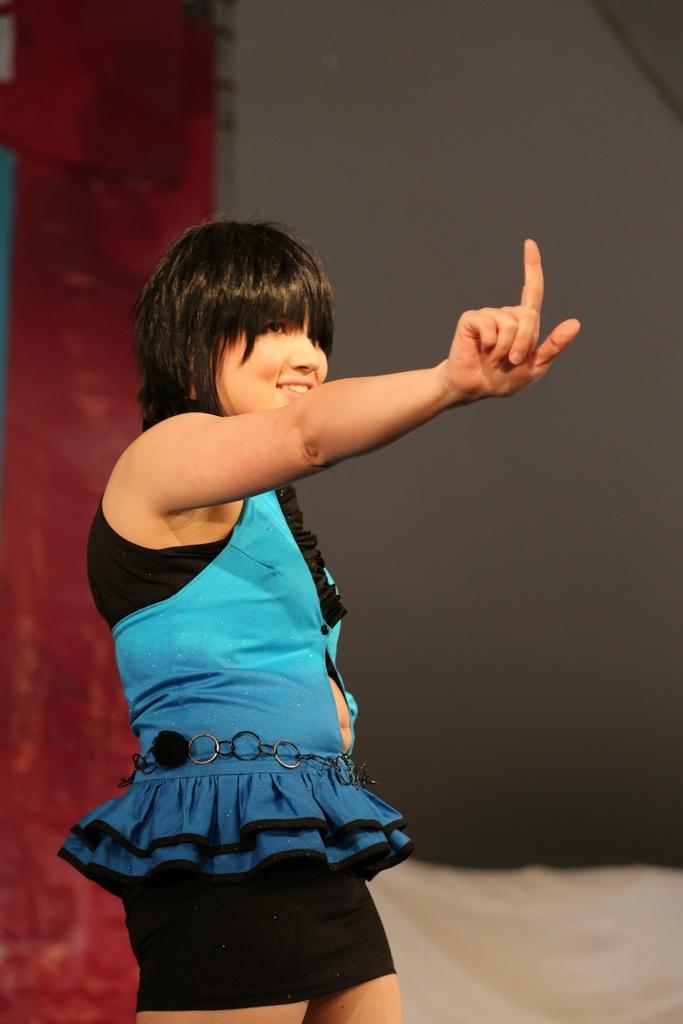Please provide a concise description of this image. In this image we can see a girl standing. In the background of the image there is a wall. 